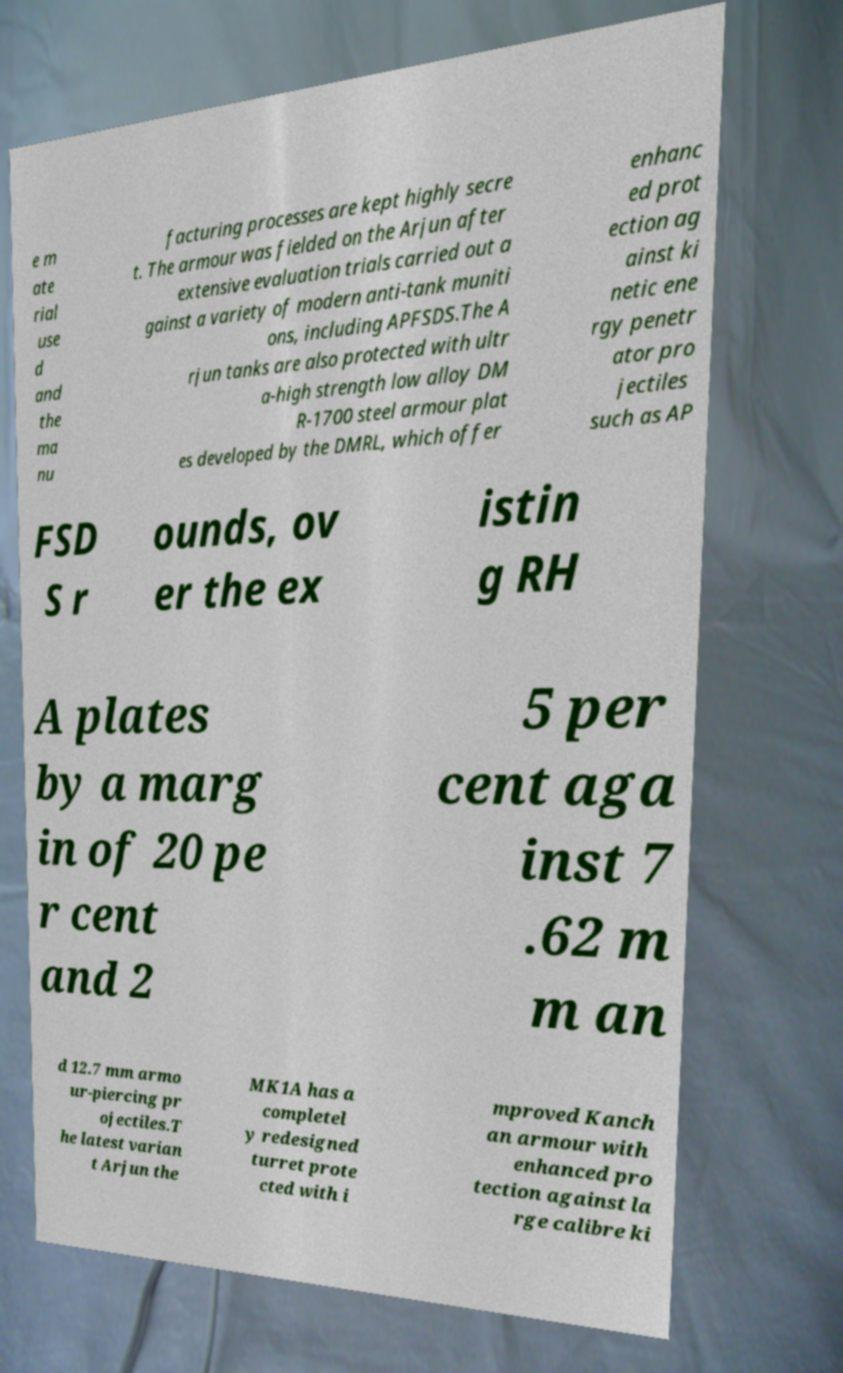Could you extract and type out the text from this image? e m ate rial use d and the ma nu facturing processes are kept highly secre t. The armour was fielded on the Arjun after extensive evaluation trials carried out a gainst a variety of modern anti-tank muniti ons, including APFSDS.The A rjun tanks are also protected with ultr a-high strength low alloy DM R-1700 steel armour plat es developed by the DMRL, which offer enhanc ed prot ection ag ainst ki netic ene rgy penetr ator pro jectiles such as AP FSD S r ounds, ov er the ex istin g RH A plates by a marg in of 20 pe r cent and 2 5 per cent aga inst 7 .62 m m an d 12.7 mm armo ur-piercing pr ojectiles.T he latest varian t Arjun the MK1A has a completel y redesigned turret prote cted with i mproved Kanch an armour with enhanced pro tection against la rge calibre ki 